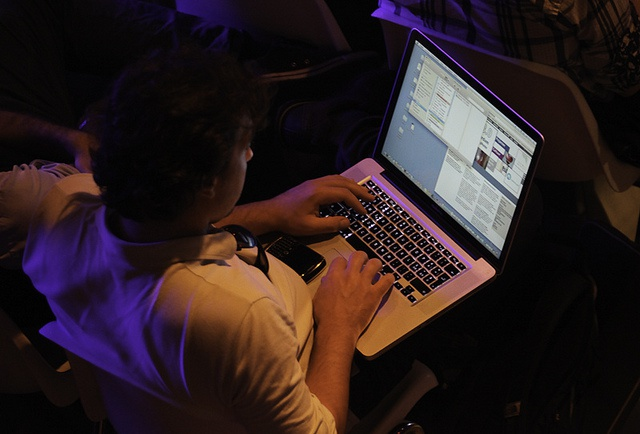Describe the objects in this image and their specific colors. I can see people in black, brown, maroon, and navy tones, laptop in black, darkgray, and brown tones, chair in black, navy, darkblue, and blue tones, chair in black, navy, and darkblue tones, and chair in navy and black tones in this image. 